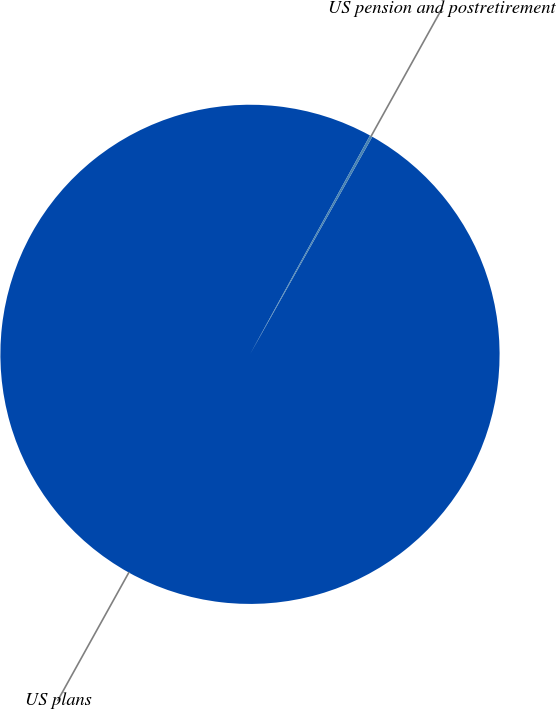Convert chart. <chart><loc_0><loc_0><loc_500><loc_500><pie_chart><fcel>US plans<fcel>US pension and postretirement<nl><fcel>99.83%<fcel>0.17%<nl></chart> 